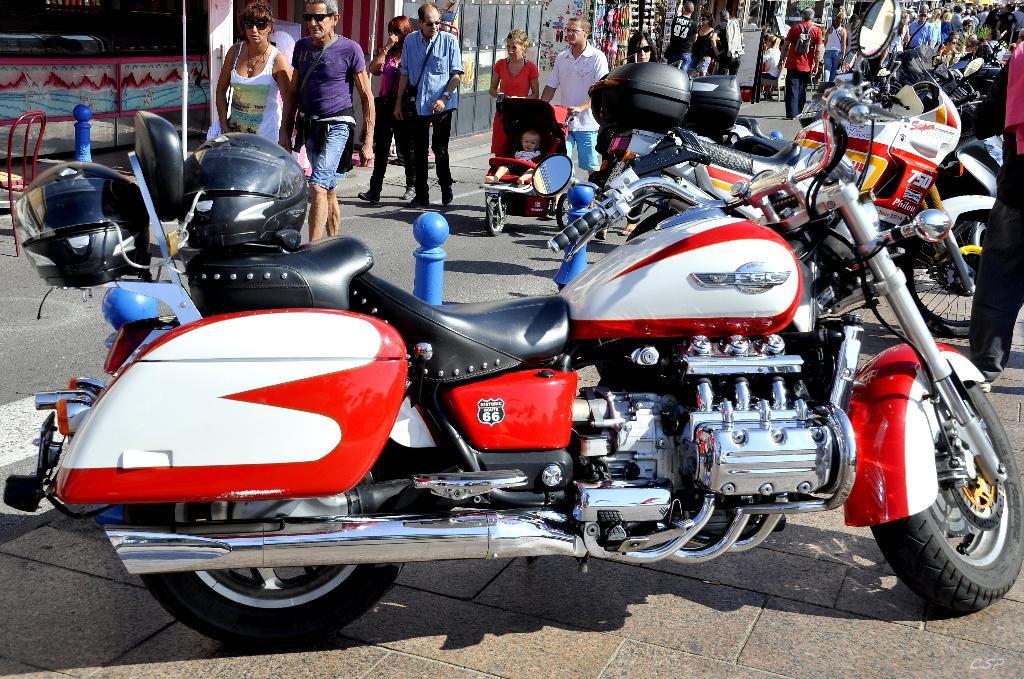What motorcycle brand is this?
Keep it short and to the point. F6c. What is the number on the black emblem?
Ensure brevity in your answer.  66. 